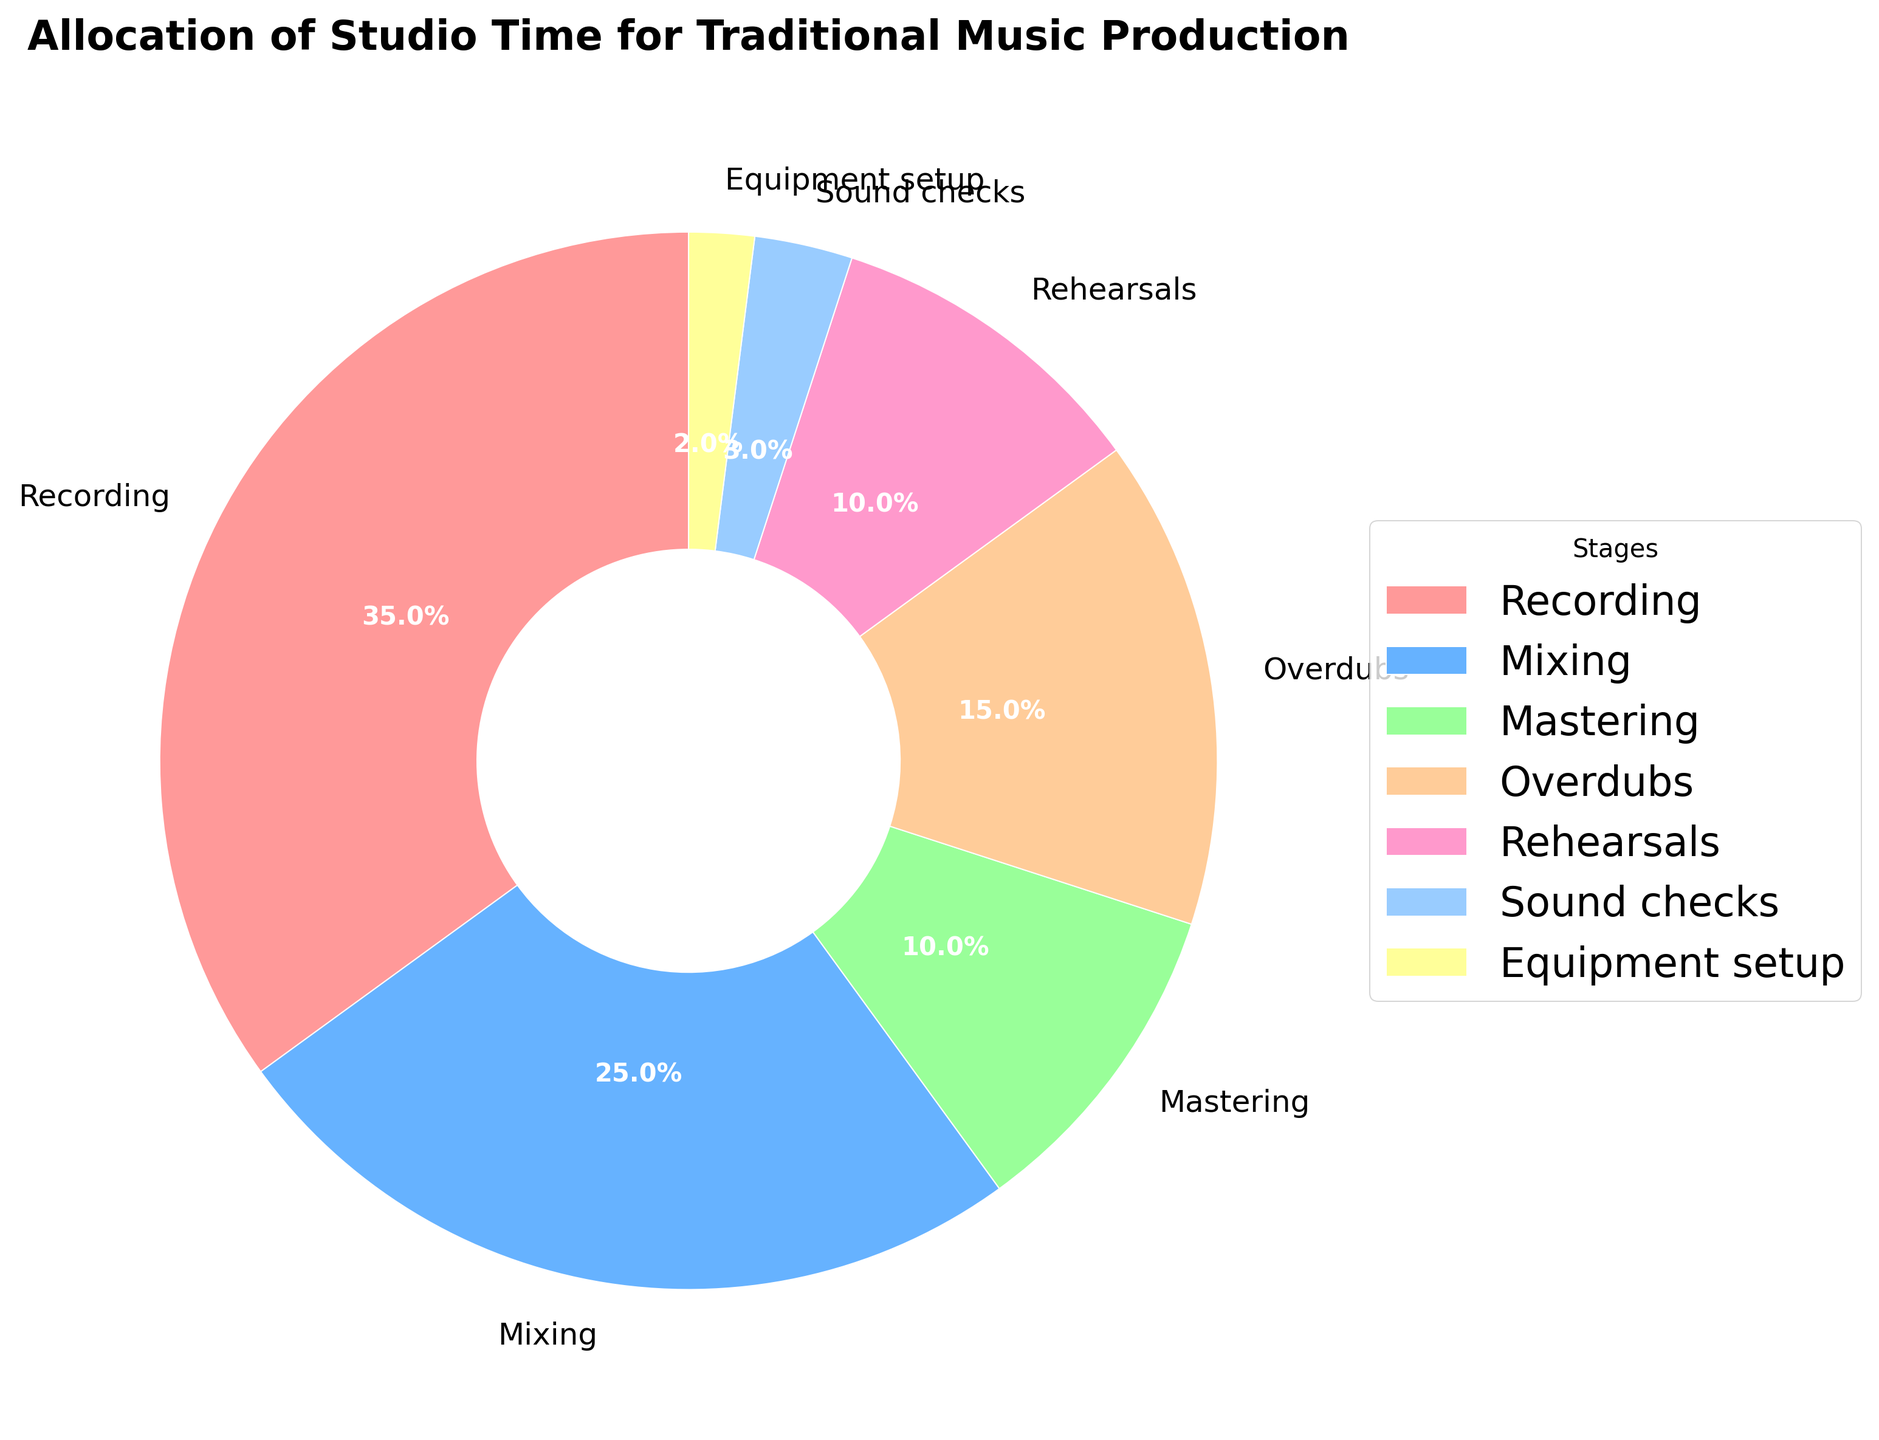What stage has the highest allocation of studio time? The pie chart visually shows that the largest segment corresponds to the "Recording" stage. By looking at the slices, "Recording" has the biggest percentage.
Answer: Recording Which two stages together account for more than 50% of the studio time? The stages "Recording" and "Mixing" when combined make up (35% + 25%) = 60%, which is more than 50%.
Answer: Recording and Mixing What is the percentage difference between the "Recording" and "Mixing" stages? The pie chart shows "Recording" at 35% and "Mixing" at 25%. The difference between these two percentages is (35% - 25%) = 10%.
Answer: 10% How do "Mastering" and "Rehearsals" compare in their allocation of studio time? From the pie chart, "Mastering" is allocated 10% of the time and "Rehearsals" also 10%. They are equal in their allocation.
Answer: They are equal What is the total percentage allocated to "Sound checks" and "Equipment setup"? The pie chart shows "Sound checks" at 3% and "Equipment setup" at 2%. Adding these together gives (3% + 2%) = 5%.
Answer: 5% Which stages have an equal share of studio time? The chart shows that both "Mastering" and "Rehearsals" each have a 10% share of studio time.
Answer: Mastering and Rehearsals If the "Overdubs" stage increased its percentage by 5%, what would its new percentage be? The current percentage for "Overdubs" is 15%. Adding 5% results in (15% + 5%) = 20%.
Answer: 20% What is the combined percentage of all stages excluding "Recording"? Excluding "Recording" which is 35%, the other stages sum up to (25% + 10% + 15% + 10% + 3% + 2%) = 65%.
Answer: 65% Which stage has the smallest allocation of studio time, and what is its percentage? The pie chart shows that "Equipment setup" has the smallest slice, which represents 2%.
Answer: Equipment setup, 2% What would be the average percentage if each stage had an equal allocation of studio time? There are 7 stages in total. If each had an equal share, the average percentage would be (100% / 7) = approximately 14.3%.
Answer: Approximately 14.3% 